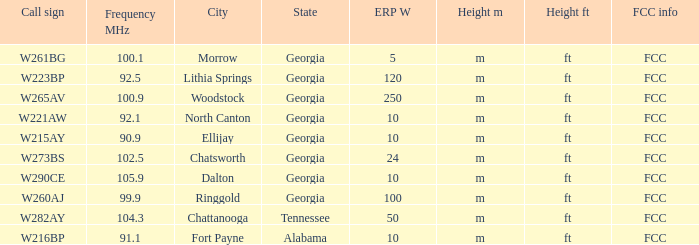How many ERP W is it that has a Call sign of w273bs? 24.0. 